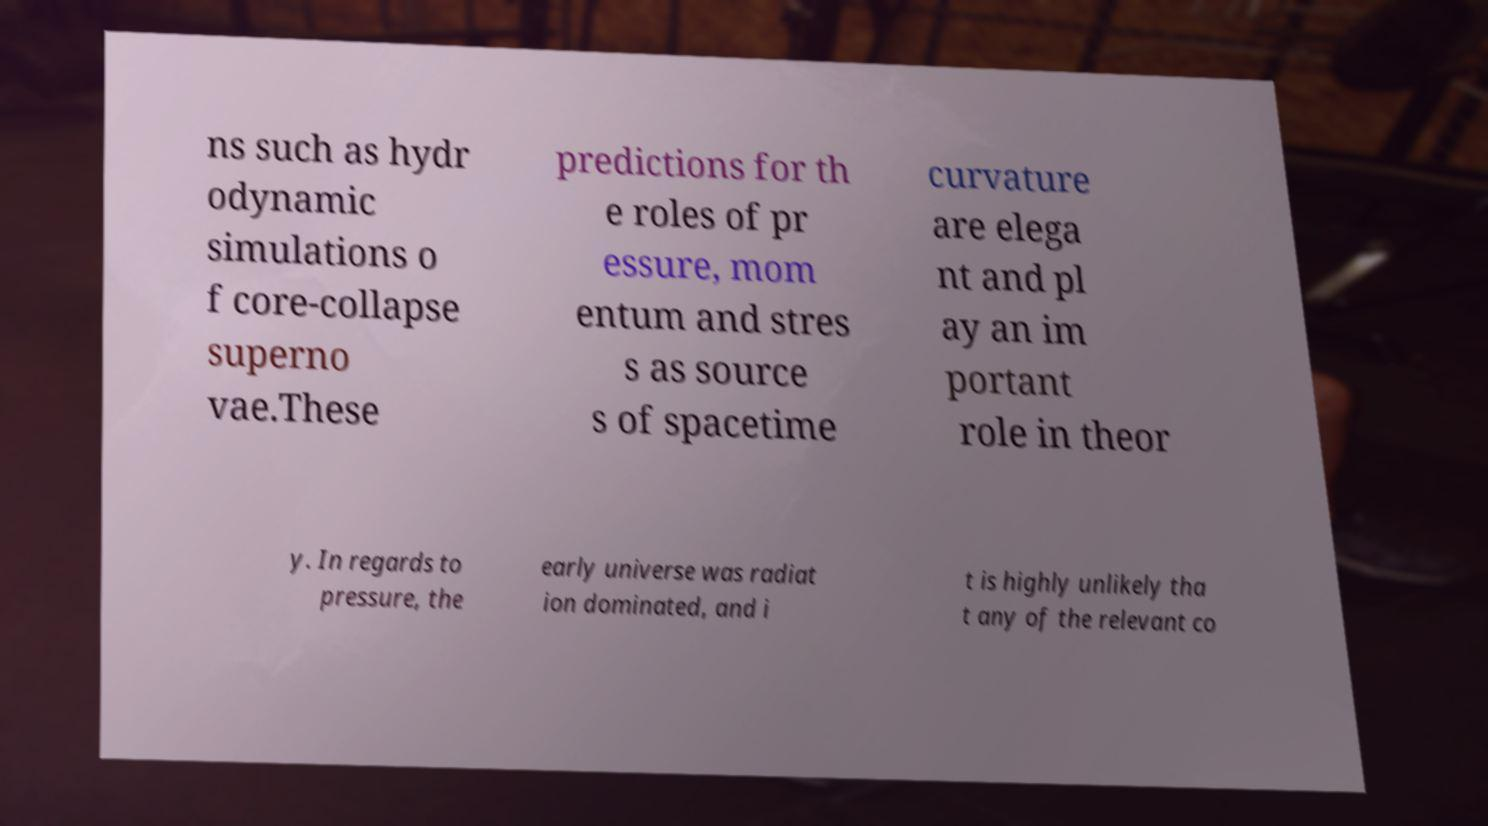Please read and relay the text visible in this image. What does it say? ns such as hydr odynamic simulations o f core-collapse superno vae.These predictions for th e roles of pr essure, mom entum and stres s as source s of spacetime curvature are elega nt and pl ay an im portant role in theor y. In regards to pressure, the early universe was radiat ion dominated, and i t is highly unlikely tha t any of the relevant co 